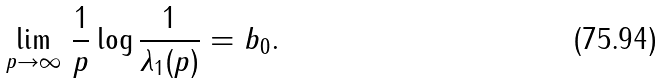Convert formula to latex. <formula><loc_0><loc_0><loc_500><loc_500>\lim _ { p \to \infty } \, \frac { 1 } { p } \log \frac { 1 } { \lambda _ { 1 } ( p ) } = b _ { 0 } .</formula> 